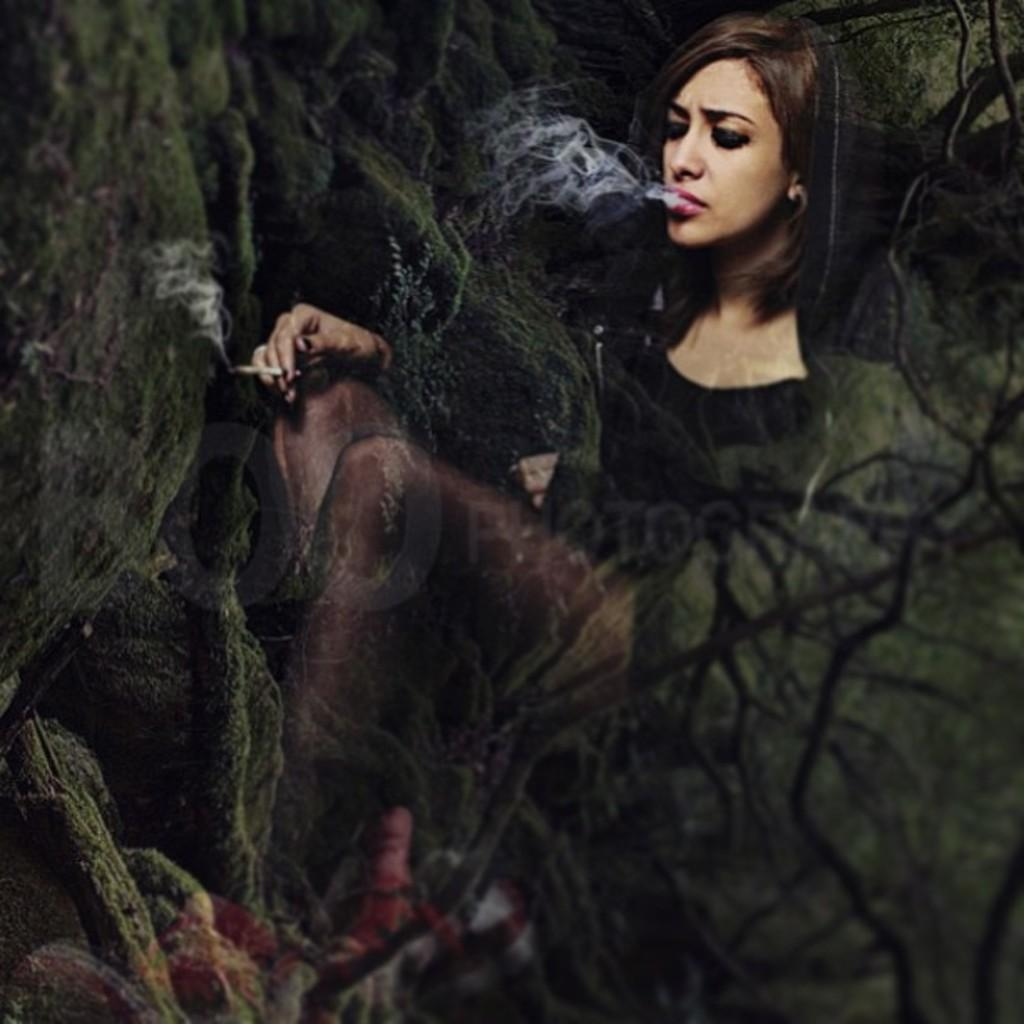What can be observed about the image itself? The image appears to be edited. Who is present in the image? There is a woman in the image. What is the woman doing in the image? The woman is smoking. What natural elements can be seen in the image? There is a tree and rocks in the image. Can you see any snow or a lake in the image? No, there is no snow or lake visible in the image. What type of paste is being used by the woman in the image? There is no paste present in the image; the woman is smoking. 